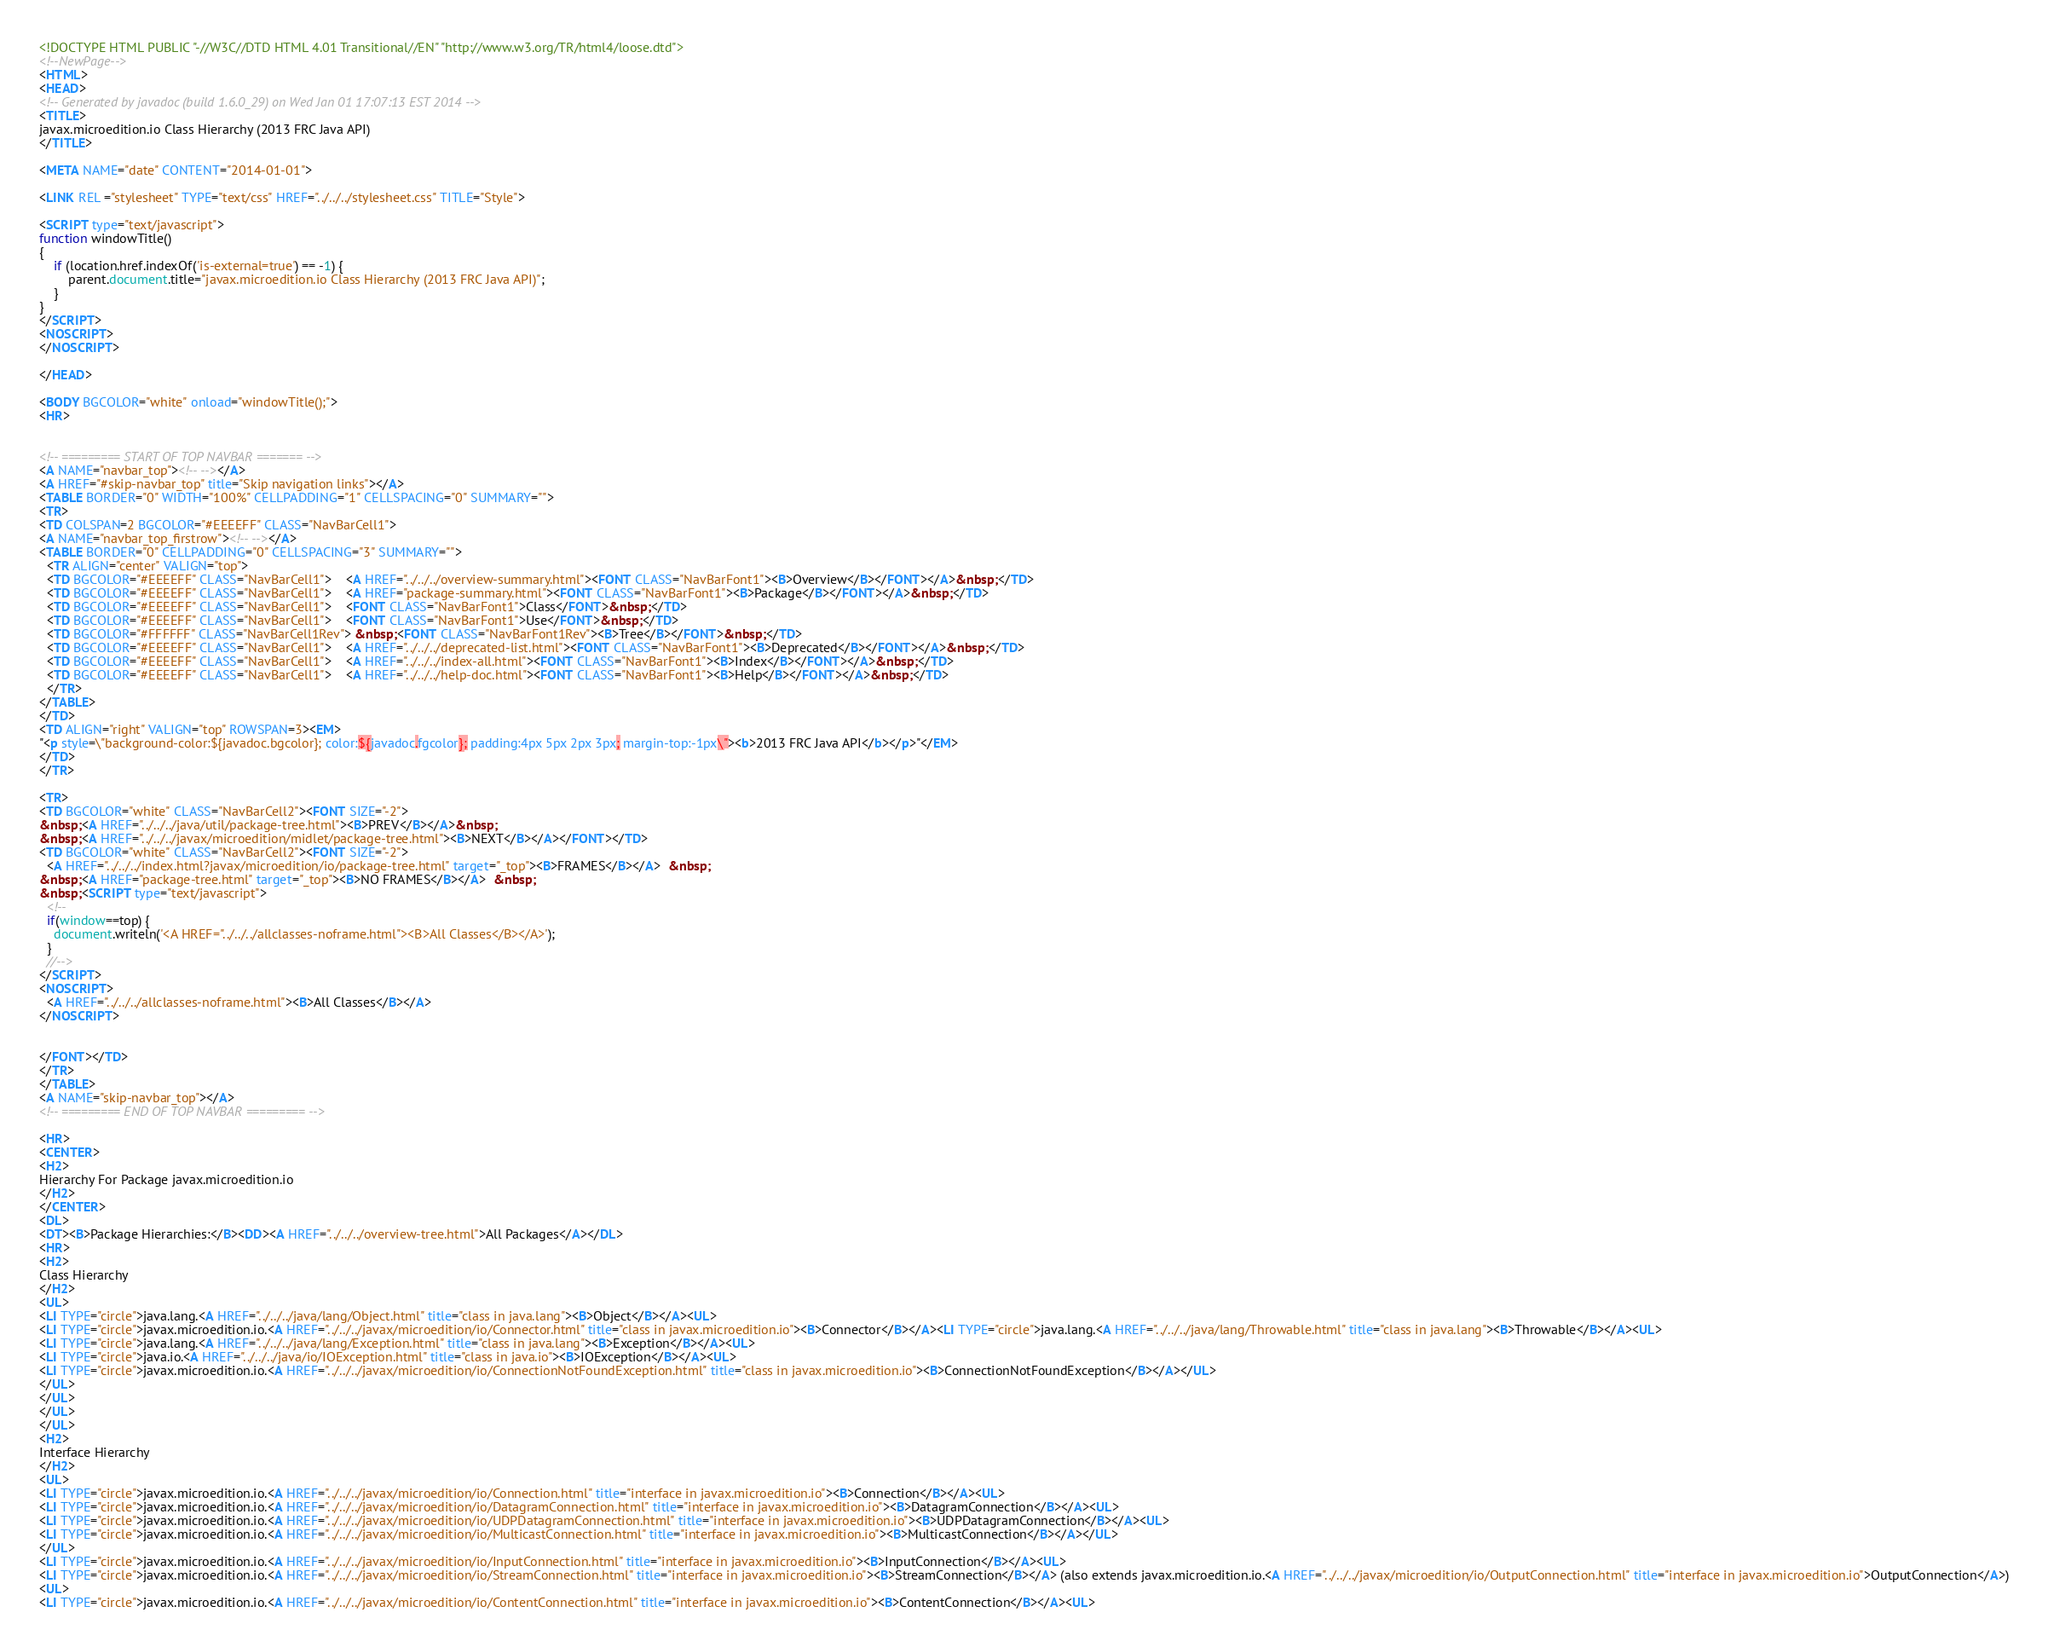<code> <loc_0><loc_0><loc_500><loc_500><_HTML_><!DOCTYPE HTML PUBLIC "-//W3C//DTD HTML 4.01 Transitional//EN" "http://www.w3.org/TR/html4/loose.dtd">
<!--NewPage-->
<HTML>
<HEAD>
<!-- Generated by javadoc (build 1.6.0_29) on Wed Jan 01 17:07:13 EST 2014 -->
<TITLE>
javax.microedition.io Class Hierarchy (2013 FRC Java API)
</TITLE>

<META NAME="date" CONTENT="2014-01-01">

<LINK REL ="stylesheet" TYPE="text/css" HREF="../../../stylesheet.css" TITLE="Style">

<SCRIPT type="text/javascript">
function windowTitle()
{
    if (location.href.indexOf('is-external=true') == -1) {
        parent.document.title="javax.microedition.io Class Hierarchy (2013 FRC Java API)";
    }
}
</SCRIPT>
<NOSCRIPT>
</NOSCRIPT>

</HEAD>

<BODY BGCOLOR="white" onload="windowTitle();">
<HR>


<!-- ========= START OF TOP NAVBAR ======= -->
<A NAME="navbar_top"><!-- --></A>
<A HREF="#skip-navbar_top" title="Skip navigation links"></A>
<TABLE BORDER="0" WIDTH="100%" CELLPADDING="1" CELLSPACING="0" SUMMARY="">
<TR>
<TD COLSPAN=2 BGCOLOR="#EEEEFF" CLASS="NavBarCell1">
<A NAME="navbar_top_firstrow"><!-- --></A>
<TABLE BORDER="0" CELLPADDING="0" CELLSPACING="3" SUMMARY="">
  <TR ALIGN="center" VALIGN="top">
  <TD BGCOLOR="#EEEEFF" CLASS="NavBarCell1">    <A HREF="../../../overview-summary.html"><FONT CLASS="NavBarFont1"><B>Overview</B></FONT></A>&nbsp;</TD>
  <TD BGCOLOR="#EEEEFF" CLASS="NavBarCell1">    <A HREF="package-summary.html"><FONT CLASS="NavBarFont1"><B>Package</B></FONT></A>&nbsp;</TD>
  <TD BGCOLOR="#EEEEFF" CLASS="NavBarCell1">    <FONT CLASS="NavBarFont1">Class</FONT>&nbsp;</TD>
  <TD BGCOLOR="#EEEEFF" CLASS="NavBarCell1">    <FONT CLASS="NavBarFont1">Use</FONT>&nbsp;</TD>
  <TD BGCOLOR="#FFFFFF" CLASS="NavBarCell1Rev"> &nbsp;<FONT CLASS="NavBarFont1Rev"><B>Tree</B></FONT>&nbsp;</TD>
  <TD BGCOLOR="#EEEEFF" CLASS="NavBarCell1">    <A HREF="../../../deprecated-list.html"><FONT CLASS="NavBarFont1"><B>Deprecated</B></FONT></A>&nbsp;</TD>
  <TD BGCOLOR="#EEEEFF" CLASS="NavBarCell1">    <A HREF="../../../index-all.html"><FONT CLASS="NavBarFont1"><B>Index</B></FONT></A>&nbsp;</TD>
  <TD BGCOLOR="#EEEEFF" CLASS="NavBarCell1">    <A HREF="../../../help-doc.html"><FONT CLASS="NavBarFont1"><B>Help</B></FONT></A>&nbsp;</TD>
  </TR>
</TABLE>
</TD>
<TD ALIGN="right" VALIGN="top" ROWSPAN=3><EM>
"<p style=\"background-color:${javadoc.bgcolor}; color:${javadoc.fgcolor}; padding:4px 5px 2px 3px; margin-top:-1px\"><b>2013 FRC Java API</b></p>"</EM>
</TD>
</TR>

<TR>
<TD BGCOLOR="white" CLASS="NavBarCell2"><FONT SIZE="-2">
&nbsp;<A HREF="../../../java/util/package-tree.html"><B>PREV</B></A>&nbsp;
&nbsp;<A HREF="../../../javax/microedition/midlet/package-tree.html"><B>NEXT</B></A></FONT></TD>
<TD BGCOLOR="white" CLASS="NavBarCell2"><FONT SIZE="-2">
  <A HREF="../../../index.html?javax/microedition/io/package-tree.html" target="_top"><B>FRAMES</B></A>  &nbsp;
&nbsp;<A HREF="package-tree.html" target="_top"><B>NO FRAMES</B></A>  &nbsp;
&nbsp;<SCRIPT type="text/javascript">
  <!--
  if(window==top) {
    document.writeln('<A HREF="../../../allclasses-noframe.html"><B>All Classes</B></A>');
  }
  //-->
</SCRIPT>
<NOSCRIPT>
  <A HREF="../../../allclasses-noframe.html"><B>All Classes</B></A>
</NOSCRIPT>


</FONT></TD>
</TR>
</TABLE>
<A NAME="skip-navbar_top"></A>
<!-- ========= END OF TOP NAVBAR ========= -->

<HR>
<CENTER>
<H2>
Hierarchy For Package javax.microedition.io
</H2>
</CENTER>
<DL>
<DT><B>Package Hierarchies:</B><DD><A HREF="../../../overview-tree.html">All Packages</A></DL>
<HR>
<H2>
Class Hierarchy
</H2>
<UL>
<LI TYPE="circle">java.lang.<A HREF="../../../java/lang/Object.html" title="class in java.lang"><B>Object</B></A><UL>
<LI TYPE="circle">javax.microedition.io.<A HREF="../../../javax/microedition/io/Connector.html" title="class in javax.microedition.io"><B>Connector</B></A><LI TYPE="circle">java.lang.<A HREF="../../../java/lang/Throwable.html" title="class in java.lang"><B>Throwable</B></A><UL>
<LI TYPE="circle">java.lang.<A HREF="../../../java/lang/Exception.html" title="class in java.lang"><B>Exception</B></A><UL>
<LI TYPE="circle">java.io.<A HREF="../../../java/io/IOException.html" title="class in java.io"><B>IOException</B></A><UL>
<LI TYPE="circle">javax.microedition.io.<A HREF="../../../javax/microedition/io/ConnectionNotFoundException.html" title="class in javax.microedition.io"><B>ConnectionNotFoundException</B></A></UL>
</UL>
</UL>
</UL>
</UL>
<H2>
Interface Hierarchy
</H2>
<UL>
<LI TYPE="circle">javax.microedition.io.<A HREF="../../../javax/microedition/io/Connection.html" title="interface in javax.microedition.io"><B>Connection</B></A><UL>
<LI TYPE="circle">javax.microedition.io.<A HREF="../../../javax/microedition/io/DatagramConnection.html" title="interface in javax.microedition.io"><B>DatagramConnection</B></A><UL>
<LI TYPE="circle">javax.microedition.io.<A HREF="../../../javax/microedition/io/UDPDatagramConnection.html" title="interface in javax.microedition.io"><B>UDPDatagramConnection</B></A><UL>
<LI TYPE="circle">javax.microedition.io.<A HREF="../../../javax/microedition/io/MulticastConnection.html" title="interface in javax.microedition.io"><B>MulticastConnection</B></A></UL>
</UL>
<LI TYPE="circle">javax.microedition.io.<A HREF="../../../javax/microedition/io/InputConnection.html" title="interface in javax.microedition.io"><B>InputConnection</B></A><UL>
<LI TYPE="circle">javax.microedition.io.<A HREF="../../../javax/microedition/io/StreamConnection.html" title="interface in javax.microedition.io"><B>StreamConnection</B></A> (also extends javax.microedition.io.<A HREF="../../../javax/microedition/io/OutputConnection.html" title="interface in javax.microedition.io">OutputConnection</A>)
<UL>
<LI TYPE="circle">javax.microedition.io.<A HREF="../../../javax/microedition/io/ContentConnection.html" title="interface in javax.microedition.io"><B>ContentConnection</B></A><UL></code> 